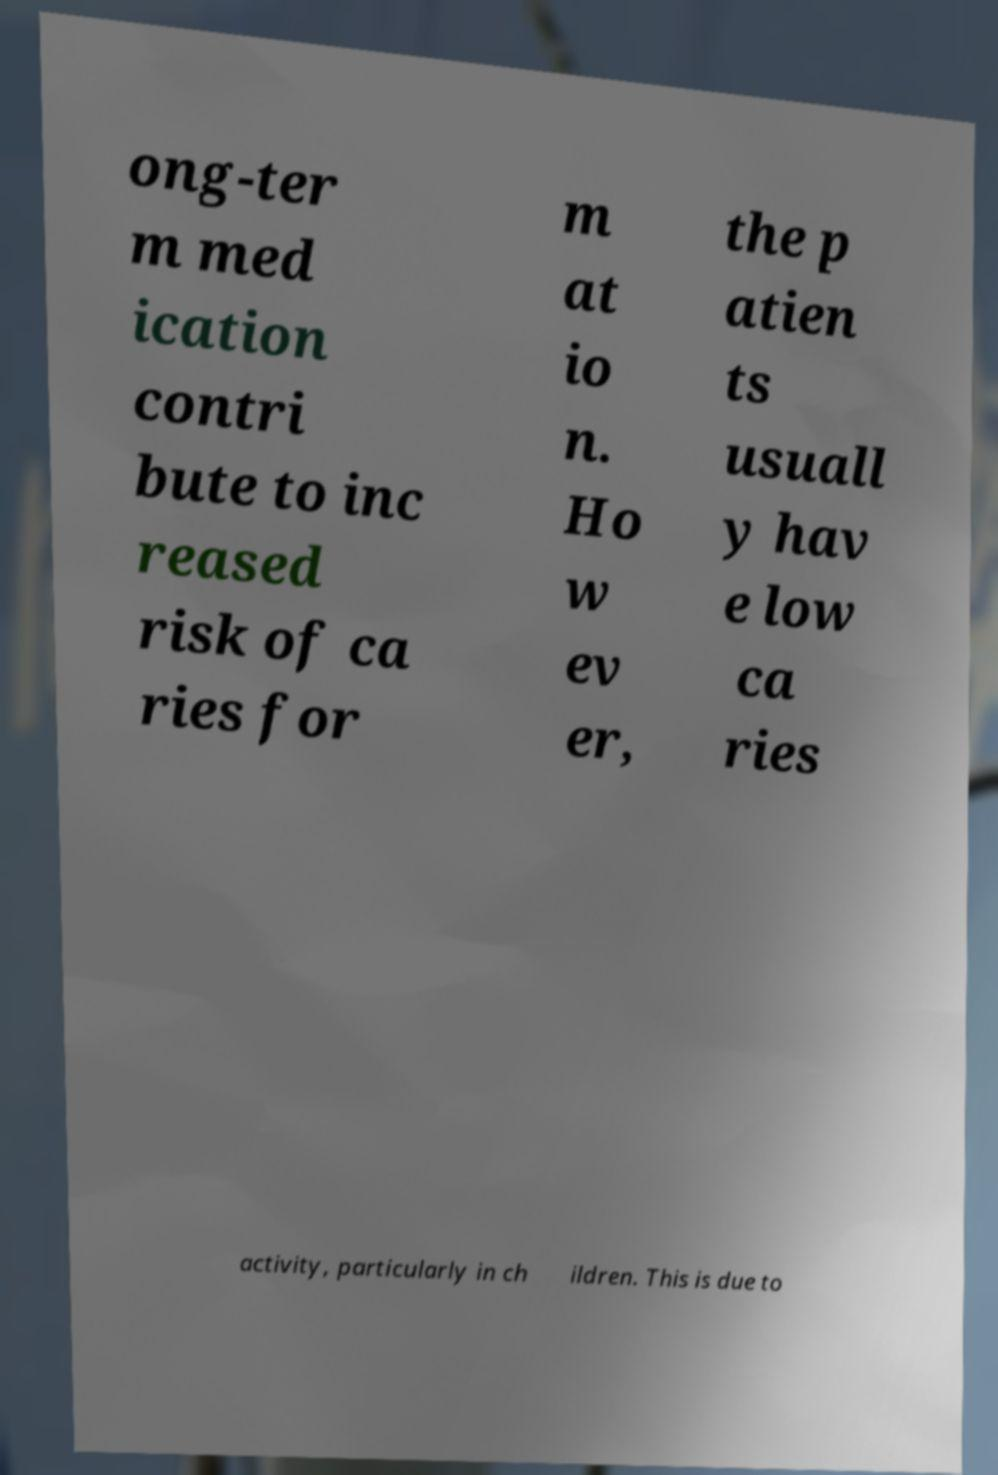There's text embedded in this image that I need extracted. Can you transcribe it verbatim? ong-ter m med ication contri bute to inc reased risk of ca ries for m at io n. Ho w ev er, the p atien ts usuall y hav e low ca ries activity, particularly in ch ildren. This is due to 